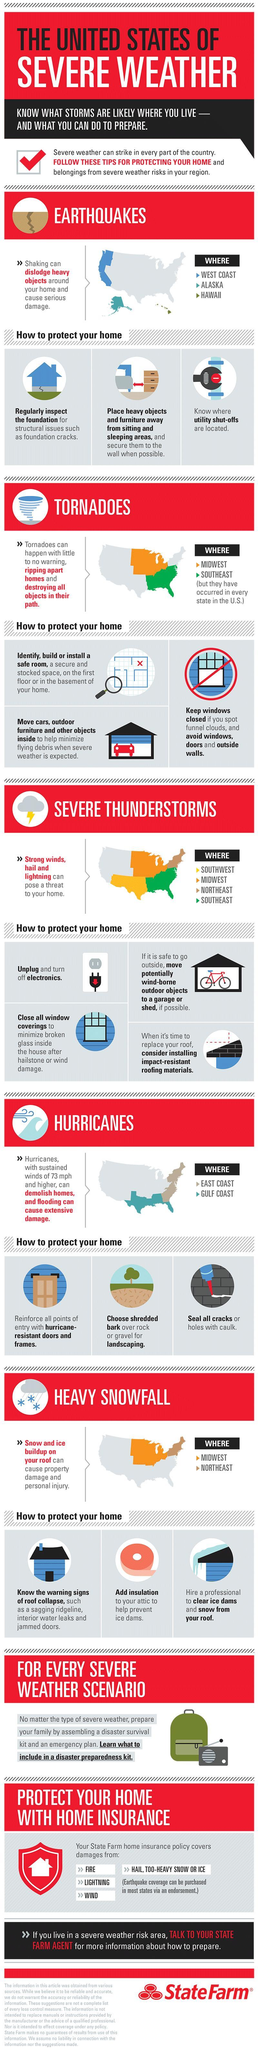Which regions of U.S are prone to heavy snowfall?
Answer the question with a short phrase. Midwest, Northeast In which coastal regions of U.S., the hurricanes can cause extensive damage? East Coast, Gulf Coast Which states/regions of U.S are more prone to earthquakes? West Coast, Alaska, Hawaii 